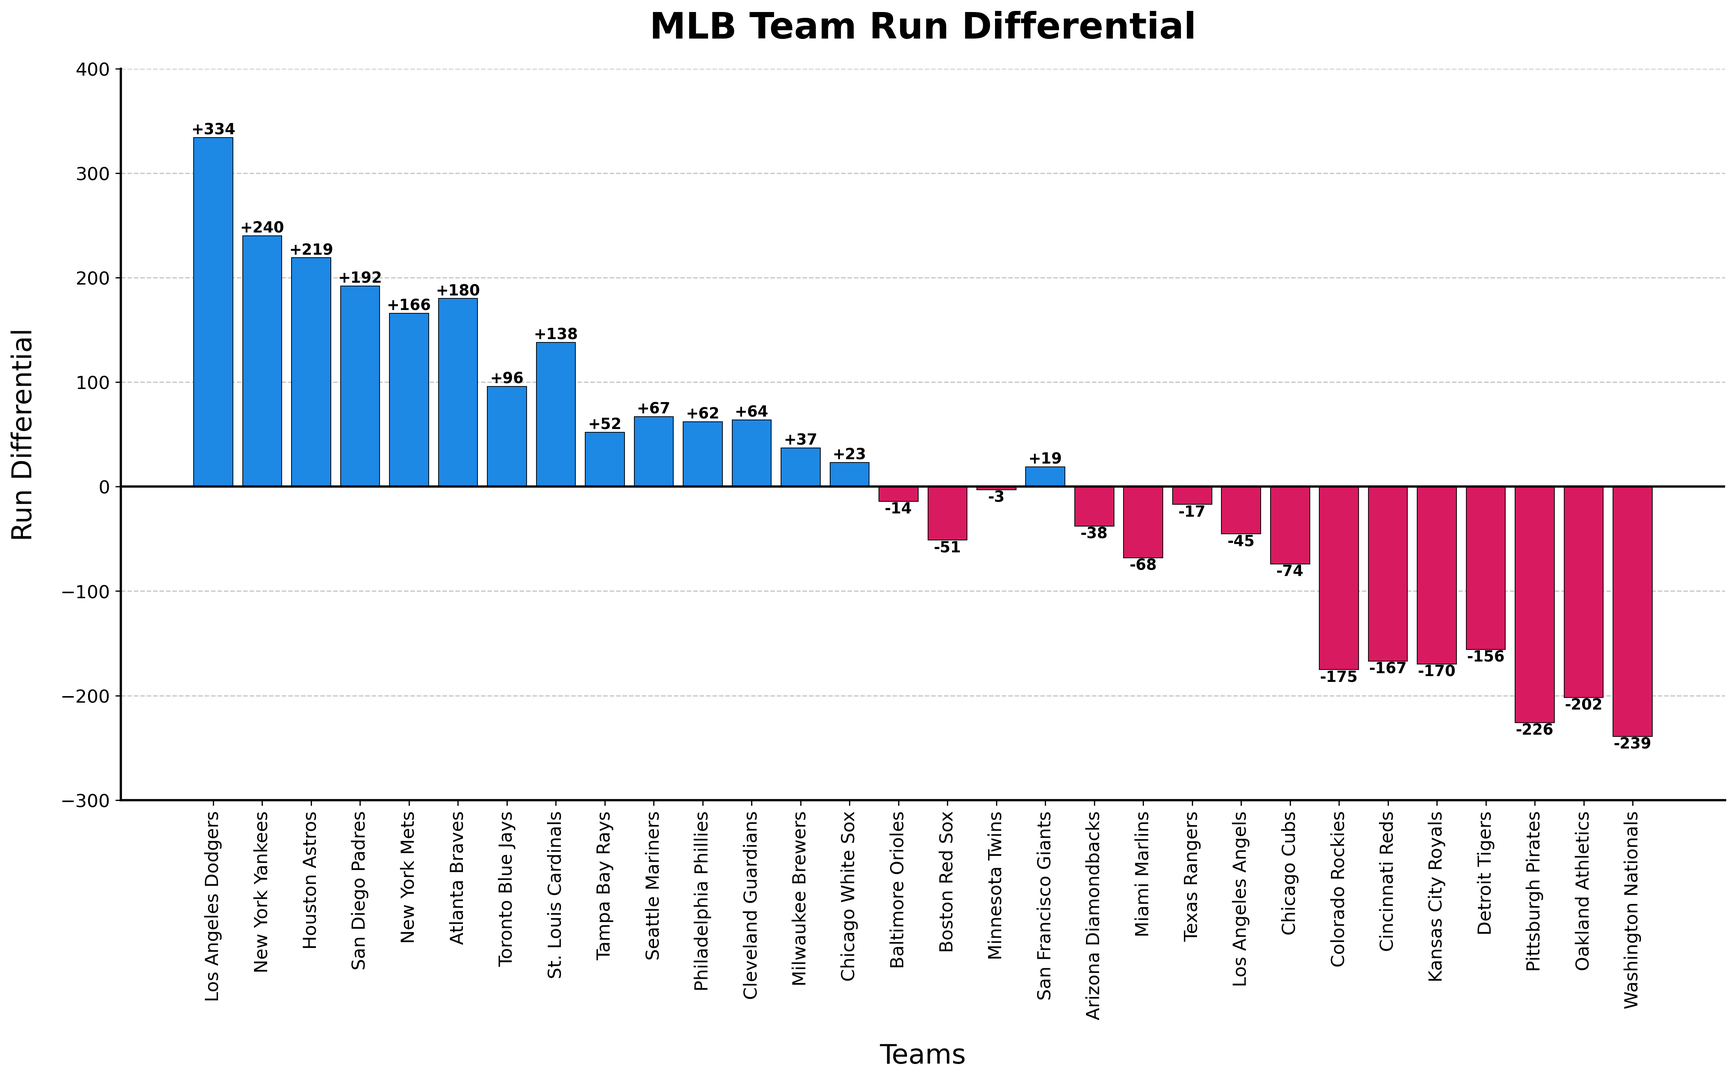Which team has the highest run differential in the previous season? The bar chart shows each team's run differential with varying heights. The Los Angeles Dodgers' bar is the highest, reaching +334.
Answer: Los Angeles Dodgers What is the median run differential of all teams? To find the median run differential, we need to list all differentials from lowest to highest. The middle value in the list is the median. For an even number of teams (30), the median is the average of the 15th and 16th values. From the figure, these are +19 (San Francisco Giants) and +23 (Chicago White Sox), so the median is (+19 + +23) / 2.
Answer: +21 Which team performed worse, the Washington Nationals or the Pittsburgh Pirates, and by how much? The height of the bars shows that the Washington Nationals have a lower run differential of -239 compared to Pittsburgh Pirates' -226. The difference is -239 - (-226) = -13 in favor of the Pirates.
Answer: Washington Nationals, by 13 runs How many teams have a negative run differential? The bars below the zero line represent negative run differentials. By counting these bars, we find that 12 teams have a negative run differential.
Answer: 12 teams What is the average run differential of the teams with positive differentials? To find the average, add all positive differentials and divide by the number of teams with positive differentials. The positive differentials are: +334, +240, +219, +192, +166, +180, +96, +138, +52, +67, +62, +64, +37, +23, +19. The sum is 1919. Dividing by 15 gives 1919 / 15.
Answer: +127.93 Which teams have a run differential between -100 and 100? Looking at the bars within the range of -100 and 100, we identify these teams: Toronto Blue Jays, Tampa Bay Rays, Seattle Mariners, Philadelphia Phillies, Cleveland Guardians, Milwaukee Brewers, Chicago White Sox, Baltimore Orioles, Minnesota Twins, San Francisco Giants, Arizona Diamondbacks, Miami Marlins, Texas Rangers, Los Angeles Angels, and Chicago Cubs.
Answer: 15 teams What is the difference in run differentials between the highest-ranked and lowest-ranked teams? The highest-run differential is +334 (Los Angeles Dodgers) and the lowest is -239 (Washington Nationals). The difference is +334 - (-239) = 573.
Answer: 573 Do more teams have a positive or negative run differential? By counting the bars above (positive) and below (negative) the zero line, we see there are 18 teams with positive run differentials and 12 with negative.
Answer: More teams have a positive run differential 